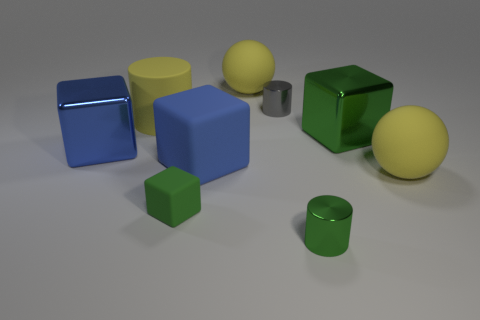Add 1 large yellow matte spheres. How many objects exist? 10 Subtract all cylinders. How many objects are left? 6 Add 5 blue rubber blocks. How many blue rubber blocks are left? 6 Add 6 large brown rubber cylinders. How many large brown rubber cylinders exist? 6 Subtract 0 purple balls. How many objects are left? 9 Subtract all big yellow rubber balls. Subtract all matte cylinders. How many objects are left? 6 